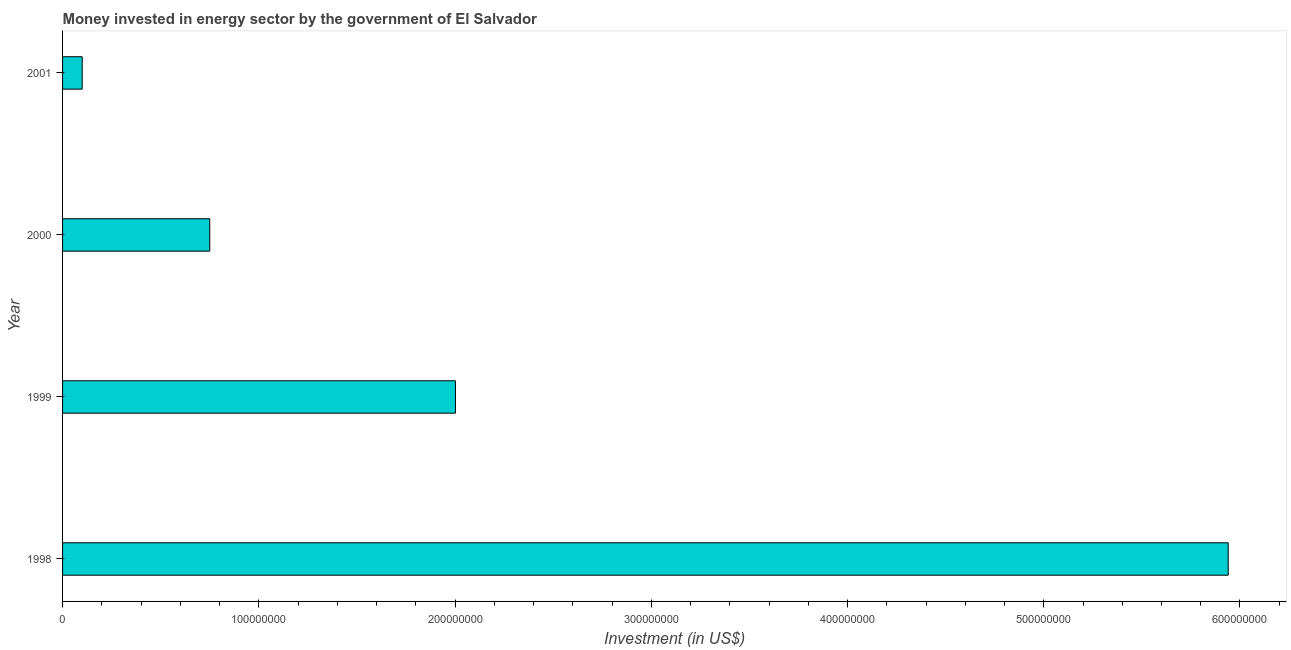Does the graph contain any zero values?
Keep it short and to the point. No. Does the graph contain grids?
Your answer should be very brief. No. What is the title of the graph?
Your answer should be compact. Money invested in energy sector by the government of El Salvador. What is the label or title of the X-axis?
Give a very brief answer. Investment (in US$). What is the label or title of the Y-axis?
Offer a very short reply. Year. What is the investment in energy in 2001?
Give a very brief answer. 1.00e+07. Across all years, what is the maximum investment in energy?
Give a very brief answer. 5.94e+08. Across all years, what is the minimum investment in energy?
Provide a short and direct response. 1.00e+07. What is the sum of the investment in energy?
Offer a terse response. 8.79e+08. What is the difference between the investment in energy in 1998 and 2000?
Keep it short and to the point. 5.19e+08. What is the average investment in energy per year?
Offer a terse response. 2.20e+08. What is the median investment in energy?
Provide a succinct answer. 1.38e+08. In how many years, is the investment in energy greater than 20000000 US$?
Make the answer very short. 3. What is the ratio of the investment in energy in 1998 to that in 2001?
Your answer should be very brief. 59.4. What is the difference between the highest and the second highest investment in energy?
Provide a succinct answer. 3.94e+08. Is the sum of the investment in energy in 1999 and 2000 greater than the maximum investment in energy across all years?
Your answer should be compact. No. What is the difference between the highest and the lowest investment in energy?
Provide a short and direct response. 5.84e+08. In how many years, is the investment in energy greater than the average investment in energy taken over all years?
Provide a succinct answer. 1. Are all the bars in the graph horizontal?
Your answer should be compact. Yes. How many years are there in the graph?
Your response must be concise. 4. What is the difference between two consecutive major ticks on the X-axis?
Make the answer very short. 1.00e+08. Are the values on the major ticks of X-axis written in scientific E-notation?
Provide a succinct answer. No. What is the Investment (in US$) in 1998?
Offer a very short reply. 5.94e+08. What is the Investment (in US$) in 1999?
Offer a very short reply. 2.00e+08. What is the Investment (in US$) in 2000?
Keep it short and to the point. 7.50e+07. What is the Investment (in US$) in 2001?
Your response must be concise. 1.00e+07. What is the difference between the Investment (in US$) in 1998 and 1999?
Your response must be concise. 3.94e+08. What is the difference between the Investment (in US$) in 1998 and 2000?
Provide a short and direct response. 5.19e+08. What is the difference between the Investment (in US$) in 1998 and 2001?
Offer a very short reply. 5.84e+08. What is the difference between the Investment (in US$) in 1999 and 2000?
Provide a succinct answer. 1.25e+08. What is the difference between the Investment (in US$) in 1999 and 2001?
Offer a terse response. 1.90e+08. What is the difference between the Investment (in US$) in 2000 and 2001?
Provide a succinct answer. 6.50e+07. What is the ratio of the Investment (in US$) in 1998 to that in 1999?
Keep it short and to the point. 2.97. What is the ratio of the Investment (in US$) in 1998 to that in 2000?
Your answer should be compact. 7.92. What is the ratio of the Investment (in US$) in 1998 to that in 2001?
Provide a succinct answer. 59.4. What is the ratio of the Investment (in US$) in 1999 to that in 2000?
Your answer should be very brief. 2.67. What is the ratio of the Investment (in US$) in 1999 to that in 2001?
Provide a succinct answer. 20.02. What is the ratio of the Investment (in US$) in 2000 to that in 2001?
Keep it short and to the point. 7.5. 